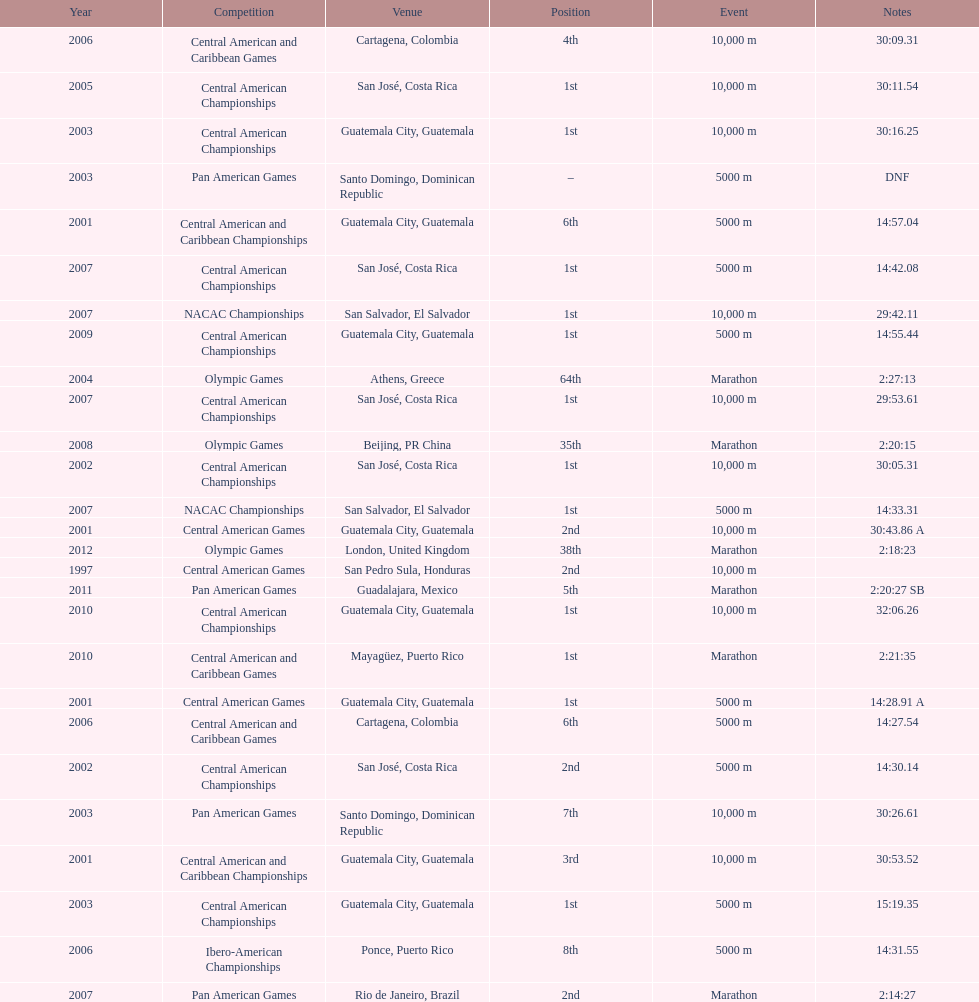What was the last competition in which a position of "2nd" was achieved? Pan American Games. Parse the full table. {'header': ['Year', 'Competition', 'Venue', 'Position', 'Event', 'Notes'], 'rows': [['2006', 'Central American and Caribbean Games', 'Cartagena, Colombia', '4th', '10,000 m', '30:09.31'], ['2005', 'Central American Championships', 'San José, Costa Rica', '1st', '10,000 m', '30:11.54'], ['2003', 'Central American Championships', 'Guatemala City, Guatemala', '1st', '10,000 m', '30:16.25'], ['2003', 'Pan American Games', 'Santo Domingo, Dominican Republic', '–', '5000 m', 'DNF'], ['2001', 'Central American and Caribbean Championships', 'Guatemala City, Guatemala', '6th', '5000 m', '14:57.04'], ['2007', 'Central American Championships', 'San José, Costa Rica', '1st', '5000 m', '14:42.08'], ['2007', 'NACAC Championships', 'San Salvador, El Salvador', '1st', '10,000 m', '29:42.11'], ['2009', 'Central American Championships', 'Guatemala City, Guatemala', '1st', '5000 m', '14:55.44'], ['2004', 'Olympic Games', 'Athens, Greece', '64th', 'Marathon', '2:27:13'], ['2007', 'Central American Championships', 'San José, Costa Rica', '1st', '10,000 m', '29:53.61'], ['2008', 'Olympic Games', 'Beijing, PR China', '35th', 'Marathon', '2:20:15'], ['2002', 'Central American Championships', 'San José, Costa Rica', '1st', '10,000 m', '30:05.31'], ['2007', 'NACAC Championships', 'San Salvador, El Salvador', '1st', '5000 m', '14:33.31'], ['2001', 'Central American Games', 'Guatemala City, Guatemala', '2nd', '10,000 m', '30:43.86 A'], ['2012', 'Olympic Games', 'London, United Kingdom', '38th', 'Marathon', '2:18:23'], ['1997', 'Central American Games', 'San Pedro Sula, Honduras', '2nd', '10,000 m', ''], ['2011', 'Pan American Games', 'Guadalajara, Mexico', '5th', 'Marathon', '2:20:27 SB'], ['2010', 'Central American Championships', 'Guatemala City, Guatemala', '1st', '10,000 m', '32:06.26'], ['2010', 'Central American and Caribbean Games', 'Mayagüez, Puerto Rico', '1st', 'Marathon', '2:21:35'], ['2001', 'Central American Games', 'Guatemala City, Guatemala', '1st', '5000 m', '14:28.91 A'], ['2006', 'Central American and Caribbean Games', 'Cartagena, Colombia', '6th', '5000 m', '14:27.54'], ['2002', 'Central American Championships', 'San José, Costa Rica', '2nd', '5000 m', '14:30.14'], ['2003', 'Pan American Games', 'Santo Domingo, Dominican Republic', '7th', '10,000 m', '30:26.61'], ['2001', 'Central American and Caribbean Championships', 'Guatemala City, Guatemala', '3rd', '10,000 m', '30:53.52'], ['2003', 'Central American Championships', 'Guatemala City, Guatemala', '1st', '5000 m', '15:19.35'], ['2006', 'Ibero-American Championships', 'Ponce, Puerto Rico', '8th', '5000 m', '14:31.55'], ['2007', 'Pan American Games', 'Rio de Janeiro, Brazil', '2nd', 'Marathon', '2:14:27']]} 